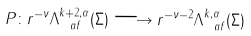<formula> <loc_0><loc_0><loc_500><loc_500>P \colon r ^ { - \nu } \Lambda ^ { k + 2 , \alpha } _ { \ a f } ( \Sigma ) \longrightarrow r ^ { - \nu - 2 } \Lambda ^ { k , \alpha } _ { \ a f } ( \Sigma )</formula> 